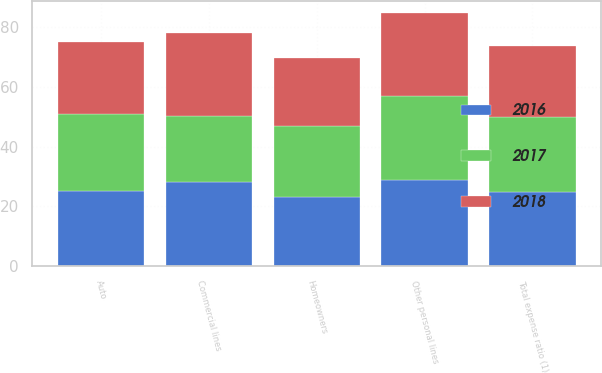<chart> <loc_0><loc_0><loc_500><loc_500><stacked_bar_chart><ecel><fcel>Auto<fcel>Homeowners<fcel>Other personal lines<fcel>Commercial lines<fcel>Total expense ratio (1)<nl><fcel>2017<fcel>25.7<fcel>23.8<fcel>28.2<fcel>21.8<fcel>25.1<nl><fcel>2016<fcel>25.1<fcel>23.2<fcel>28.8<fcel>28.3<fcel>24.7<nl><fcel>2018<fcel>24.2<fcel>22.7<fcel>27.6<fcel>27.8<fcel>23.9<nl></chart> 